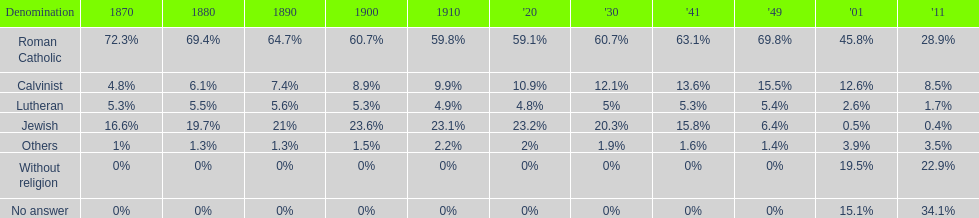During 2011, what was the cumulative percentage of people who considered themselves religious? 43%. 